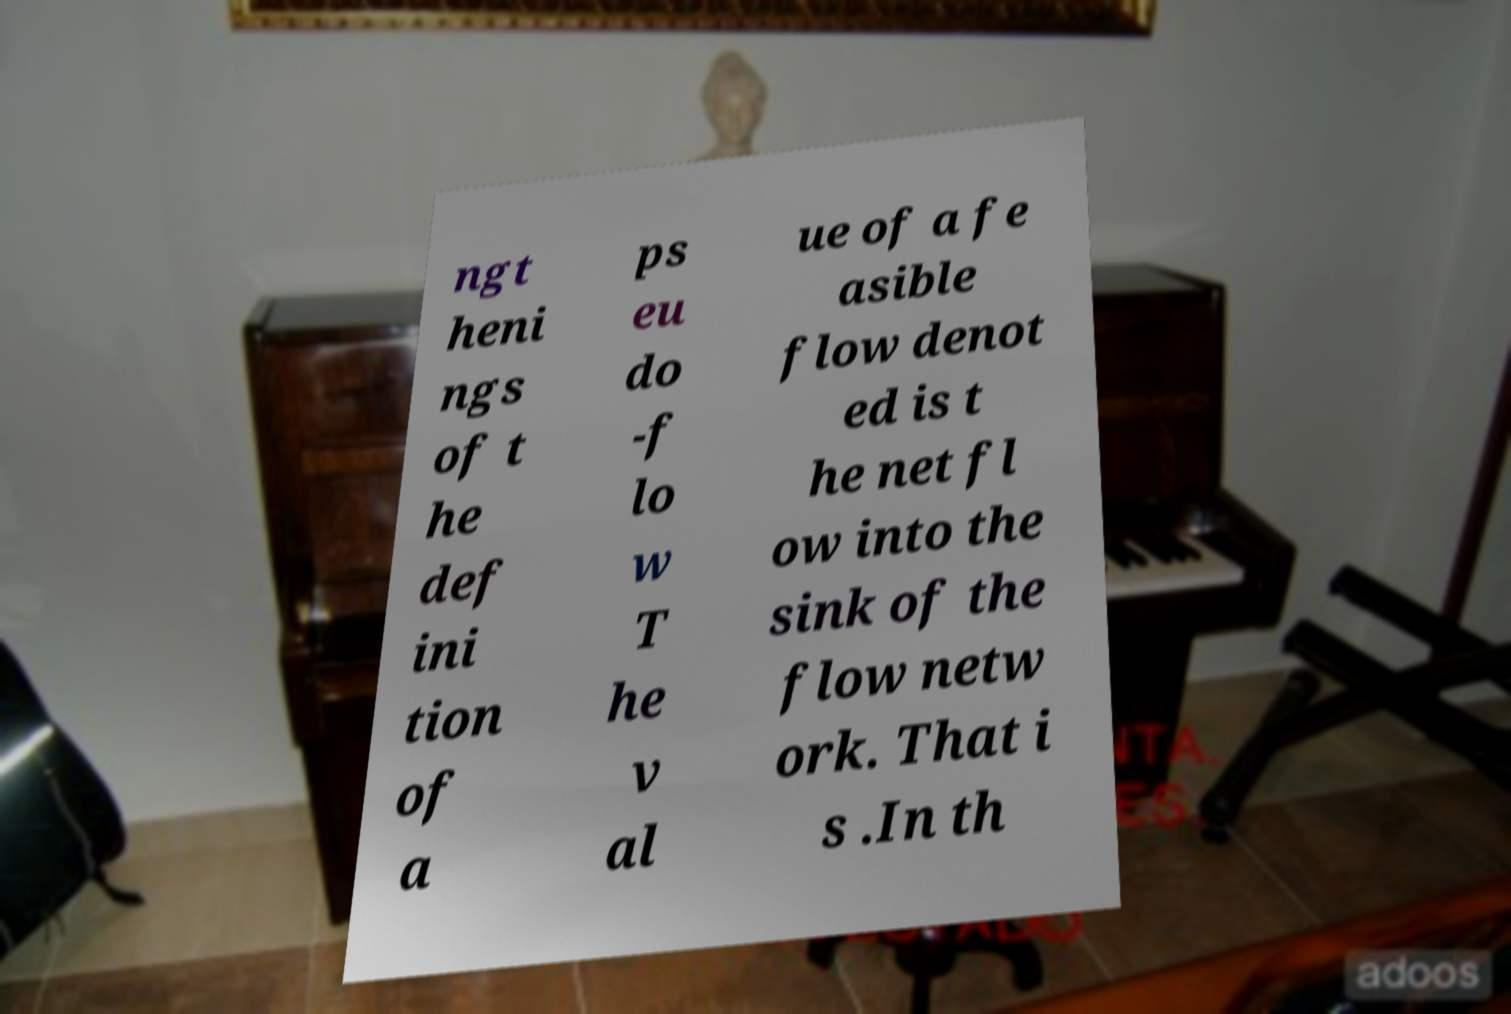Can you read and provide the text displayed in the image?This photo seems to have some interesting text. Can you extract and type it out for me? ngt heni ngs of t he def ini tion of a ps eu do -f lo w T he v al ue of a fe asible flow denot ed is t he net fl ow into the sink of the flow netw ork. That i s .In th 